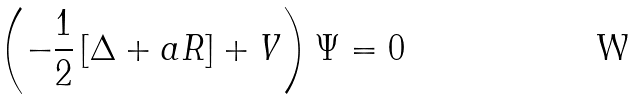<formula> <loc_0><loc_0><loc_500><loc_500>\left ( - \frac { 1 } { 2 } \left [ \Delta + a R \right ] + V \right ) \Psi = 0</formula> 